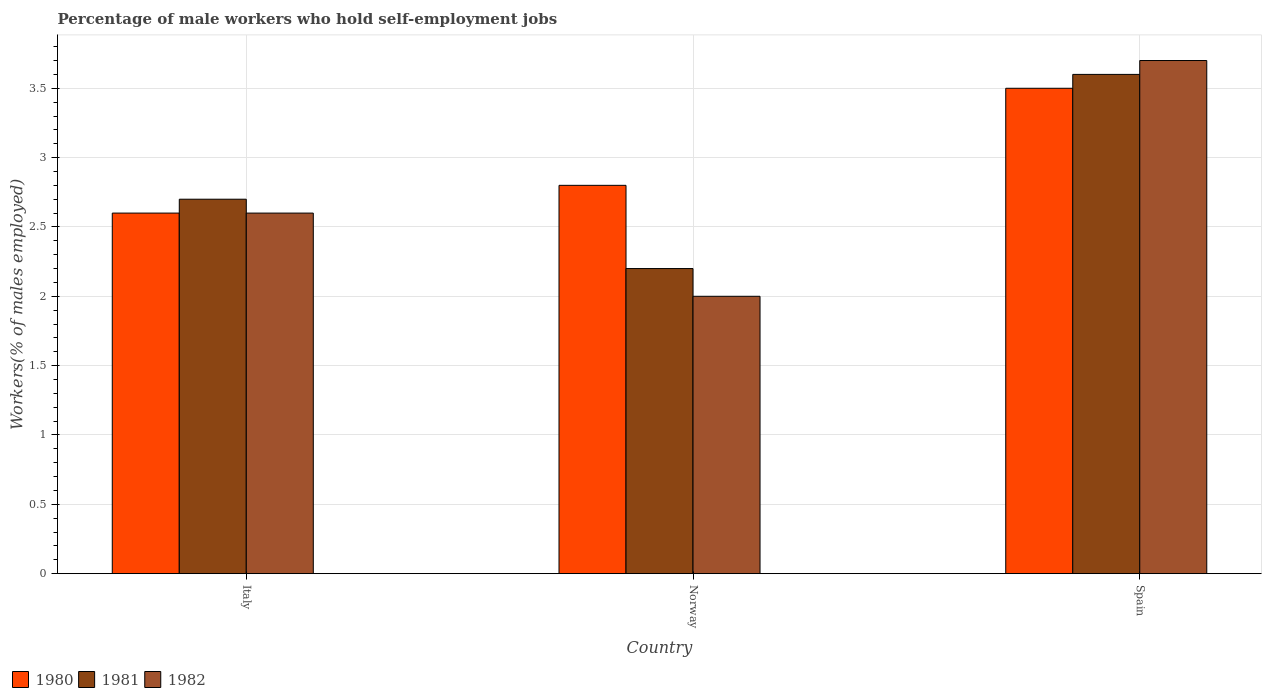How many different coloured bars are there?
Make the answer very short. 3. Are the number of bars per tick equal to the number of legend labels?
Provide a succinct answer. Yes. Are the number of bars on each tick of the X-axis equal?
Ensure brevity in your answer.  Yes. How many bars are there on the 1st tick from the left?
Give a very brief answer. 3. What is the percentage of self-employed male workers in 1980 in Norway?
Provide a short and direct response. 2.8. Across all countries, what is the maximum percentage of self-employed male workers in 1980?
Provide a short and direct response. 3.5. Across all countries, what is the minimum percentage of self-employed male workers in 1982?
Offer a terse response. 2. In which country was the percentage of self-employed male workers in 1980 maximum?
Provide a succinct answer. Spain. What is the total percentage of self-employed male workers in 1982 in the graph?
Your response must be concise. 8.3. What is the difference between the percentage of self-employed male workers in 1982 in Norway and that in Spain?
Provide a succinct answer. -1.7. What is the difference between the percentage of self-employed male workers in 1982 in Italy and the percentage of self-employed male workers in 1980 in Norway?
Give a very brief answer. -0.2. What is the average percentage of self-employed male workers in 1981 per country?
Give a very brief answer. 2.83. What is the difference between the percentage of self-employed male workers of/in 1981 and percentage of self-employed male workers of/in 1980 in Spain?
Ensure brevity in your answer.  0.1. In how many countries, is the percentage of self-employed male workers in 1981 greater than 3.7 %?
Your answer should be very brief. 0. What is the ratio of the percentage of self-employed male workers in 1981 in Italy to that in Norway?
Provide a succinct answer. 1.23. Is the percentage of self-employed male workers in 1981 in Norway less than that in Spain?
Offer a very short reply. Yes. What is the difference between the highest and the lowest percentage of self-employed male workers in 1982?
Offer a very short reply. 1.7. Is the sum of the percentage of self-employed male workers in 1980 in Italy and Spain greater than the maximum percentage of self-employed male workers in 1981 across all countries?
Your answer should be compact. Yes. Is it the case that in every country, the sum of the percentage of self-employed male workers in 1982 and percentage of self-employed male workers in 1981 is greater than the percentage of self-employed male workers in 1980?
Ensure brevity in your answer.  Yes. How many bars are there?
Ensure brevity in your answer.  9. How many countries are there in the graph?
Keep it short and to the point. 3. What is the difference between two consecutive major ticks on the Y-axis?
Make the answer very short. 0.5. Are the values on the major ticks of Y-axis written in scientific E-notation?
Offer a terse response. No. Does the graph contain grids?
Provide a succinct answer. Yes. Where does the legend appear in the graph?
Keep it short and to the point. Bottom left. What is the title of the graph?
Your answer should be very brief. Percentage of male workers who hold self-employment jobs. Does "2007" appear as one of the legend labels in the graph?
Provide a short and direct response. No. What is the label or title of the Y-axis?
Your answer should be compact. Workers(% of males employed). What is the Workers(% of males employed) in 1980 in Italy?
Your response must be concise. 2.6. What is the Workers(% of males employed) in 1981 in Italy?
Ensure brevity in your answer.  2.7. What is the Workers(% of males employed) of 1982 in Italy?
Ensure brevity in your answer.  2.6. What is the Workers(% of males employed) in 1980 in Norway?
Provide a succinct answer. 2.8. What is the Workers(% of males employed) in 1981 in Norway?
Your answer should be compact. 2.2. What is the Workers(% of males employed) in 1982 in Norway?
Keep it short and to the point. 2. What is the Workers(% of males employed) of 1980 in Spain?
Ensure brevity in your answer.  3.5. What is the Workers(% of males employed) in 1981 in Spain?
Your answer should be very brief. 3.6. What is the Workers(% of males employed) in 1982 in Spain?
Offer a terse response. 3.7. Across all countries, what is the maximum Workers(% of males employed) of 1980?
Your answer should be compact. 3.5. Across all countries, what is the maximum Workers(% of males employed) in 1981?
Your response must be concise. 3.6. Across all countries, what is the maximum Workers(% of males employed) of 1982?
Ensure brevity in your answer.  3.7. Across all countries, what is the minimum Workers(% of males employed) in 1980?
Your response must be concise. 2.6. Across all countries, what is the minimum Workers(% of males employed) of 1981?
Make the answer very short. 2.2. Across all countries, what is the minimum Workers(% of males employed) in 1982?
Your answer should be very brief. 2. What is the total Workers(% of males employed) of 1981 in the graph?
Keep it short and to the point. 8.5. What is the difference between the Workers(% of males employed) of 1980 in Italy and that in Norway?
Your answer should be compact. -0.2. What is the difference between the Workers(% of males employed) of 1981 in Italy and that in Norway?
Your response must be concise. 0.5. What is the difference between the Workers(% of males employed) of 1982 in Italy and that in Norway?
Your response must be concise. 0.6. What is the difference between the Workers(% of males employed) of 1982 in Italy and that in Spain?
Keep it short and to the point. -1.1. What is the difference between the Workers(% of males employed) in 1980 in Norway and that in Spain?
Your response must be concise. -0.7. What is the difference between the Workers(% of males employed) in 1981 in Norway and that in Spain?
Ensure brevity in your answer.  -1.4. What is the difference between the Workers(% of males employed) in 1980 in Italy and the Workers(% of males employed) in 1981 in Norway?
Make the answer very short. 0.4. What is the difference between the Workers(% of males employed) in 1981 in Italy and the Workers(% of males employed) in 1982 in Norway?
Your answer should be very brief. 0.7. What is the difference between the Workers(% of males employed) in 1980 in Italy and the Workers(% of males employed) in 1981 in Spain?
Your answer should be compact. -1. What is the difference between the Workers(% of males employed) in 1980 in Italy and the Workers(% of males employed) in 1982 in Spain?
Make the answer very short. -1.1. What is the average Workers(% of males employed) of 1980 per country?
Make the answer very short. 2.97. What is the average Workers(% of males employed) of 1981 per country?
Provide a short and direct response. 2.83. What is the average Workers(% of males employed) of 1982 per country?
Your response must be concise. 2.77. What is the difference between the Workers(% of males employed) in 1980 and Workers(% of males employed) in 1981 in Italy?
Provide a short and direct response. -0.1. What is the difference between the Workers(% of males employed) in 1980 and Workers(% of males employed) in 1982 in Italy?
Ensure brevity in your answer.  0. What is the difference between the Workers(% of males employed) of 1980 and Workers(% of males employed) of 1981 in Norway?
Make the answer very short. 0.6. What is the difference between the Workers(% of males employed) of 1980 and Workers(% of males employed) of 1982 in Norway?
Offer a terse response. 0.8. What is the difference between the Workers(% of males employed) in 1981 and Workers(% of males employed) in 1982 in Spain?
Offer a terse response. -0.1. What is the ratio of the Workers(% of males employed) in 1980 in Italy to that in Norway?
Ensure brevity in your answer.  0.93. What is the ratio of the Workers(% of males employed) of 1981 in Italy to that in Norway?
Your answer should be compact. 1.23. What is the ratio of the Workers(% of males employed) in 1980 in Italy to that in Spain?
Keep it short and to the point. 0.74. What is the ratio of the Workers(% of males employed) of 1982 in Italy to that in Spain?
Offer a terse response. 0.7. What is the ratio of the Workers(% of males employed) in 1981 in Norway to that in Spain?
Offer a very short reply. 0.61. What is the ratio of the Workers(% of males employed) of 1982 in Norway to that in Spain?
Give a very brief answer. 0.54. What is the difference between the highest and the second highest Workers(% of males employed) in 1980?
Give a very brief answer. 0.7. What is the difference between the highest and the second highest Workers(% of males employed) of 1981?
Provide a succinct answer. 0.9. What is the difference between the highest and the lowest Workers(% of males employed) of 1980?
Provide a succinct answer. 0.9. What is the difference between the highest and the lowest Workers(% of males employed) of 1982?
Ensure brevity in your answer.  1.7. 